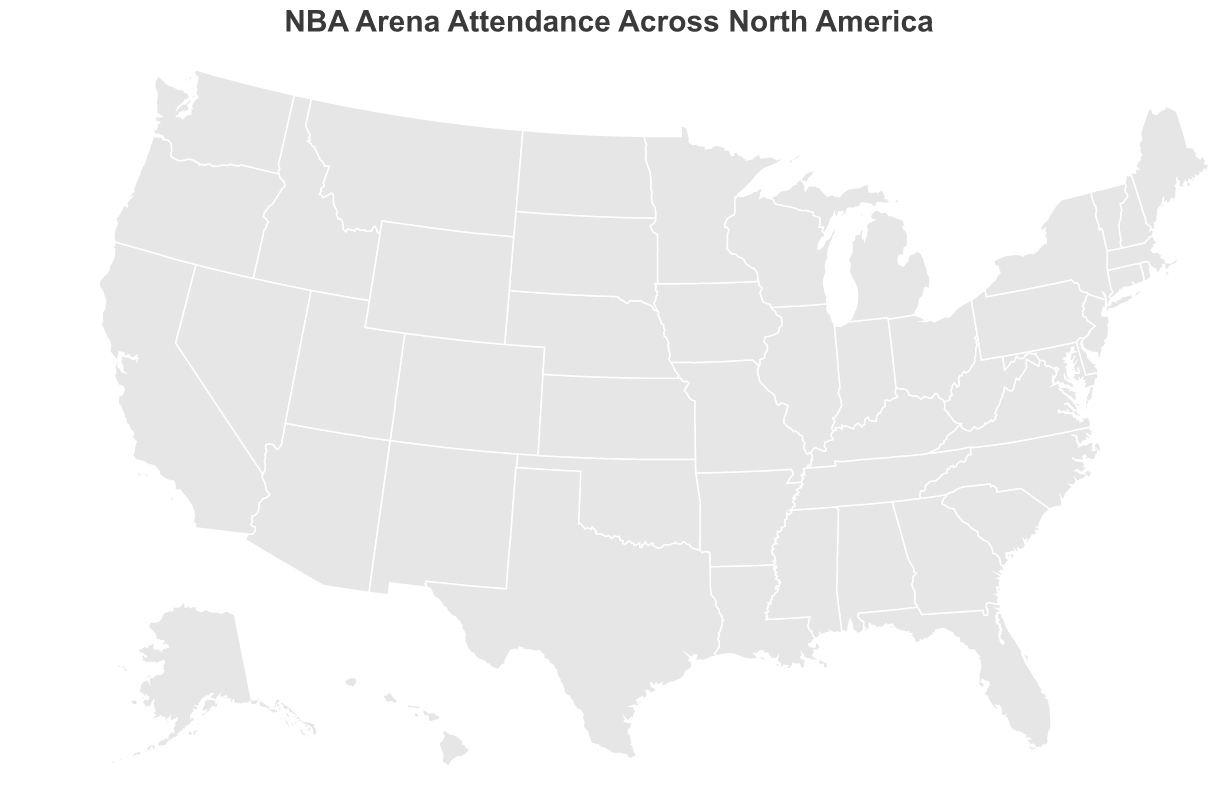What's the highest average attendance among the NBA arenas? Look for the largest circle on the map, hover over it to check the details, and find Chicago's United Center with an average attendance of 20,776.
Answer: 20,776 Which city has the lowest average attendance for NBA games? Look for the smallest circle on the map, hover over it to get the details, and find Memphis's FedExForum with an average attendance of 15,631.
Answer: Memphis How do the attendance rates of New York and Los Angeles compare? Compare the average attendance values of Madison Square Garden (New York) and Crypto.com Arena (Los Angeles): 19,812 for New York and 18,997 for Los Angeles.
Answer: New York has higher attendance than Los Angeles What is the sum of the average attendance for NBA games in Boston and Miami? Add the average attendance of TD Garden (Boston) and FTX Arena (Miami): 19,156 (Boston) + 19,600 (Miami) = 38,756.
Answer: 38,756 Which arena in the western United States has the highest attendance? Check the locations and hover over circles in the western U.S. to find the highest attendance, which is the Crypto.com Arena (Los Angeles Lakers) with 18,997.
Answer: Crypto.com Arena What can you tell about the distribution of attendance for NBA games in the Midwest? Look for circles in the Midwest and compare their sizes and colors. Notably, Chicago's United Center has the highest attendance (20,776), while Milwaukee's Fiserv Forum has a lower attendance (17,341).
Answer: Midwest has varying attendance rates with Chicago being the highest Are there any outliers in terms of average attendance? Observe if there are any circles that significantly stand out. Chicago's average attendance (20,776) might be considered an outlier since it is higher than the rest.
Answer: Chicago Which U.S. coastal city has the highest NBA game attendance? Compare the attendance values for coastal cities: New York (19,812), Miami (19,600), San Francisco (18,064), Los Angeles (18,997).
Answer: New York What is the average attendance across all listed arenas? Sum all the average attendances and divide by the number of arenas: (19,812 + 18,997 + 20,776 + 19,156 + 19,600 + 18,064 + 19,816 + 20,422 + 19,800 + 17,071 + 18,315 + 17,341 + 19,393 + 19,432 + 15,631) / 15 ≈ 18,869.
Answer: 18,869 Which team has its arena located furthest west? Check the longitudes of the cities and find the one with the highest negative value: San Francisco (Golden State Warriors) with a longitude of -122.3877.
Answer: Golden State Warriors 